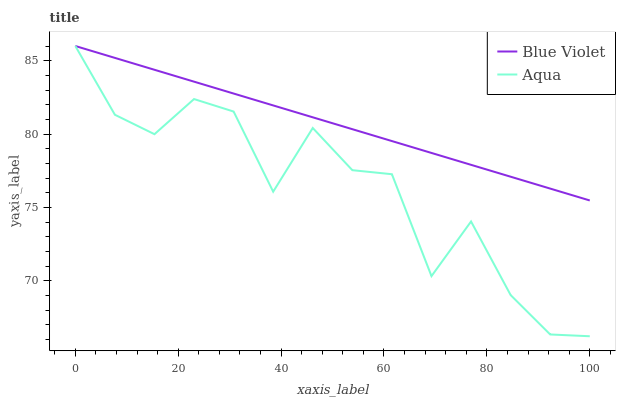Does Blue Violet have the minimum area under the curve?
Answer yes or no. No. Is Blue Violet the roughest?
Answer yes or no. No. Does Blue Violet have the lowest value?
Answer yes or no. No. 